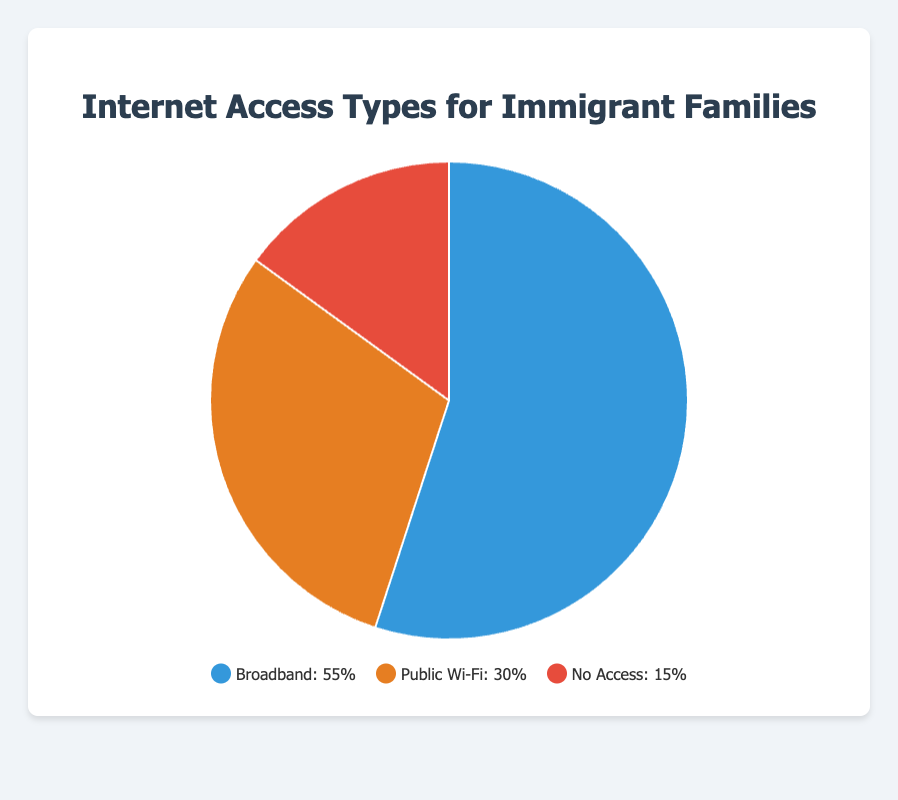What is the most common type of internet access for immigrant families? By looking at the pie chart, we see that the largest section is labeled “Broadband,” with a percentage of 55%. Therefore, the most common type of internet access is Broadband.
Answer: Broadband What percentage of immigrant families use Public Wi-Fi for internet access? The pie chart shows that the section labeled “Public Wi-Fi” has a percentage of 30%.
Answer: 30% How does the percentage of immigrant families with no internet access compare to those with broadband access? Comparing the percentages, Broadband is 55% and No Access is 15%. 55% is greater than 15%, so significantly more families have broadband access than no access.
Answer: More families have broadband access What is the total percentage of immigrant families with some form of internet access? To find the total, add the percentages of families with Broadband and Public Wi-Fi: 55% + 30% = 85%.
Answer: 85% What is the difference in percentage points between Broadband and Public Wi-Fi usage among immigrant families? Subtract the percentage of Public Wi-Fi from Broadband: 55% - 30% = 25%.
Answer: 25% What color represents the section for immigrant families with no internet access on the pie chart? Visually identifying the section labeled “No Access,” it is represented by the color red.
Answer: Red Which internet access type for immigrant families has the smallest representation on the pie chart? The smallest section of the pie chart is labeled “No Access,” representing 15%.
Answer: No Access How much larger, in percentage points, is the Public Wi-Fi section compared to the No Access section? Subtract the percentage of No Access from Public Wi-Fi: 30% - 15% = 15%.
Answer: 15% What is the sum of the percentages of Broadband and Public Wi-Fi access for immigrant families? Add the percentages of Broadband and Public Wi-Fi: 55% + 30% = 85%.
Answer: 85% If the No Access percentage increases by 5%, how would the total percentage of families with some form of internet access change? Adding 5% to No Access would make it 20%. The total percentage of families with some form of internet access would decrease by 5%, so 85% - 5% = 80%.
Answer: 80% 